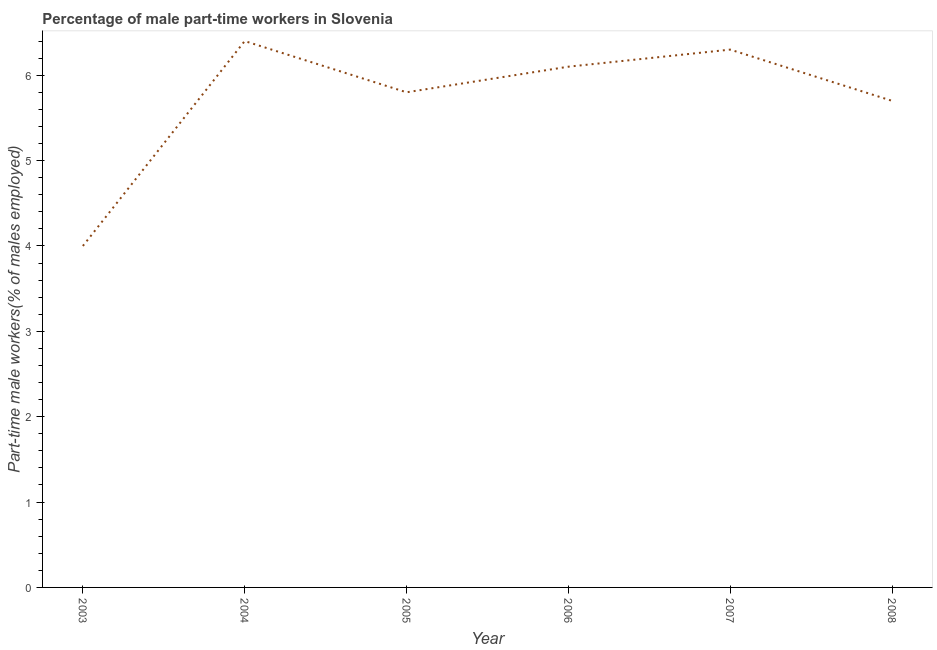What is the percentage of part-time male workers in 2005?
Keep it short and to the point. 5.8. Across all years, what is the maximum percentage of part-time male workers?
Offer a terse response. 6.4. What is the sum of the percentage of part-time male workers?
Make the answer very short. 34.3. What is the difference between the percentage of part-time male workers in 2004 and 2006?
Your response must be concise. 0.3. What is the average percentage of part-time male workers per year?
Your response must be concise. 5.72. What is the median percentage of part-time male workers?
Your answer should be compact. 5.95. In how many years, is the percentage of part-time male workers greater than 5.2 %?
Your answer should be compact. 5. What is the ratio of the percentage of part-time male workers in 2003 to that in 2006?
Your answer should be compact. 0.66. Is the percentage of part-time male workers in 2004 less than that in 2008?
Offer a very short reply. No. Is the difference between the percentage of part-time male workers in 2003 and 2007 greater than the difference between any two years?
Make the answer very short. No. What is the difference between the highest and the second highest percentage of part-time male workers?
Give a very brief answer. 0.1. Is the sum of the percentage of part-time male workers in 2004 and 2006 greater than the maximum percentage of part-time male workers across all years?
Provide a succinct answer. Yes. What is the difference between the highest and the lowest percentage of part-time male workers?
Offer a terse response. 2.4. Does the percentage of part-time male workers monotonically increase over the years?
Provide a succinct answer. No. What is the difference between two consecutive major ticks on the Y-axis?
Your answer should be compact. 1. Are the values on the major ticks of Y-axis written in scientific E-notation?
Keep it short and to the point. No. Does the graph contain any zero values?
Ensure brevity in your answer.  No. What is the title of the graph?
Offer a terse response. Percentage of male part-time workers in Slovenia. What is the label or title of the Y-axis?
Offer a very short reply. Part-time male workers(% of males employed). What is the Part-time male workers(% of males employed) of 2004?
Make the answer very short. 6.4. What is the Part-time male workers(% of males employed) in 2005?
Offer a terse response. 5.8. What is the Part-time male workers(% of males employed) of 2006?
Provide a short and direct response. 6.1. What is the Part-time male workers(% of males employed) in 2007?
Your answer should be very brief. 6.3. What is the Part-time male workers(% of males employed) in 2008?
Give a very brief answer. 5.7. What is the difference between the Part-time male workers(% of males employed) in 2003 and 2004?
Ensure brevity in your answer.  -2.4. What is the difference between the Part-time male workers(% of males employed) in 2003 and 2005?
Keep it short and to the point. -1.8. What is the difference between the Part-time male workers(% of males employed) in 2003 and 2006?
Your answer should be compact. -2.1. What is the difference between the Part-time male workers(% of males employed) in 2003 and 2007?
Your answer should be compact. -2.3. What is the difference between the Part-time male workers(% of males employed) in 2004 and 2005?
Your answer should be very brief. 0.6. What is the difference between the Part-time male workers(% of males employed) in 2004 and 2007?
Ensure brevity in your answer.  0.1. What is the difference between the Part-time male workers(% of males employed) in 2004 and 2008?
Keep it short and to the point. 0.7. What is the difference between the Part-time male workers(% of males employed) in 2005 and 2006?
Your answer should be very brief. -0.3. What is the difference between the Part-time male workers(% of males employed) in 2006 and 2008?
Make the answer very short. 0.4. What is the difference between the Part-time male workers(% of males employed) in 2007 and 2008?
Your answer should be very brief. 0.6. What is the ratio of the Part-time male workers(% of males employed) in 2003 to that in 2004?
Offer a terse response. 0.62. What is the ratio of the Part-time male workers(% of males employed) in 2003 to that in 2005?
Ensure brevity in your answer.  0.69. What is the ratio of the Part-time male workers(% of males employed) in 2003 to that in 2006?
Keep it short and to the point. 0.66. What is the ratio of the Part-time male workers(% of males employed) in 2003 to that in 2007?
Provide a short and direct response. 0.64. What is the ratio of the Part-time male workers(% of males employed) in 2003 to that in 2008?
Provide a short and direct response. 0.7. What is the ratio of the Part-time male workers(% of males employed) in 2004 to that in 2005?
Your response must be concise. 1.1. What is the ratio of the Part-time male workers(% of males employed) in 2004 to that in 2006?
Give a very brief answer. 1.05. What is the ratio of the Part-time male workers(% of males employed) in 2004 to that in 2007?
Provide a succinct answer. 1.02. What is the ratio of the Part-time male workers(% of males employed) in 2004 to that in 2008?
Provide a short and direct response. 1.12. What is the ratio of the Part-time male workers(% of males employed) in 2005 to that in 2006?
Your answer should be very brief. 0.95. What is the ratio of the Part-time male workers(% of males employed) in 2005 to that in 2007?
Your answer should be very brief. 0.92. What is the ratio of the Part-time male workers(% of males employed) in 2006 to that in 2007?
Provide a short and direct response. 0.97. What is the ratio of the Part-time male workers(% of males employed) in 2006 to that in 2008?
Provide a succinct answer. 1.07. What is the ratio of the Part-time male workers(% of males employed) in 2007 to that in 2008?
Keep it short and to the point. 1.1. 